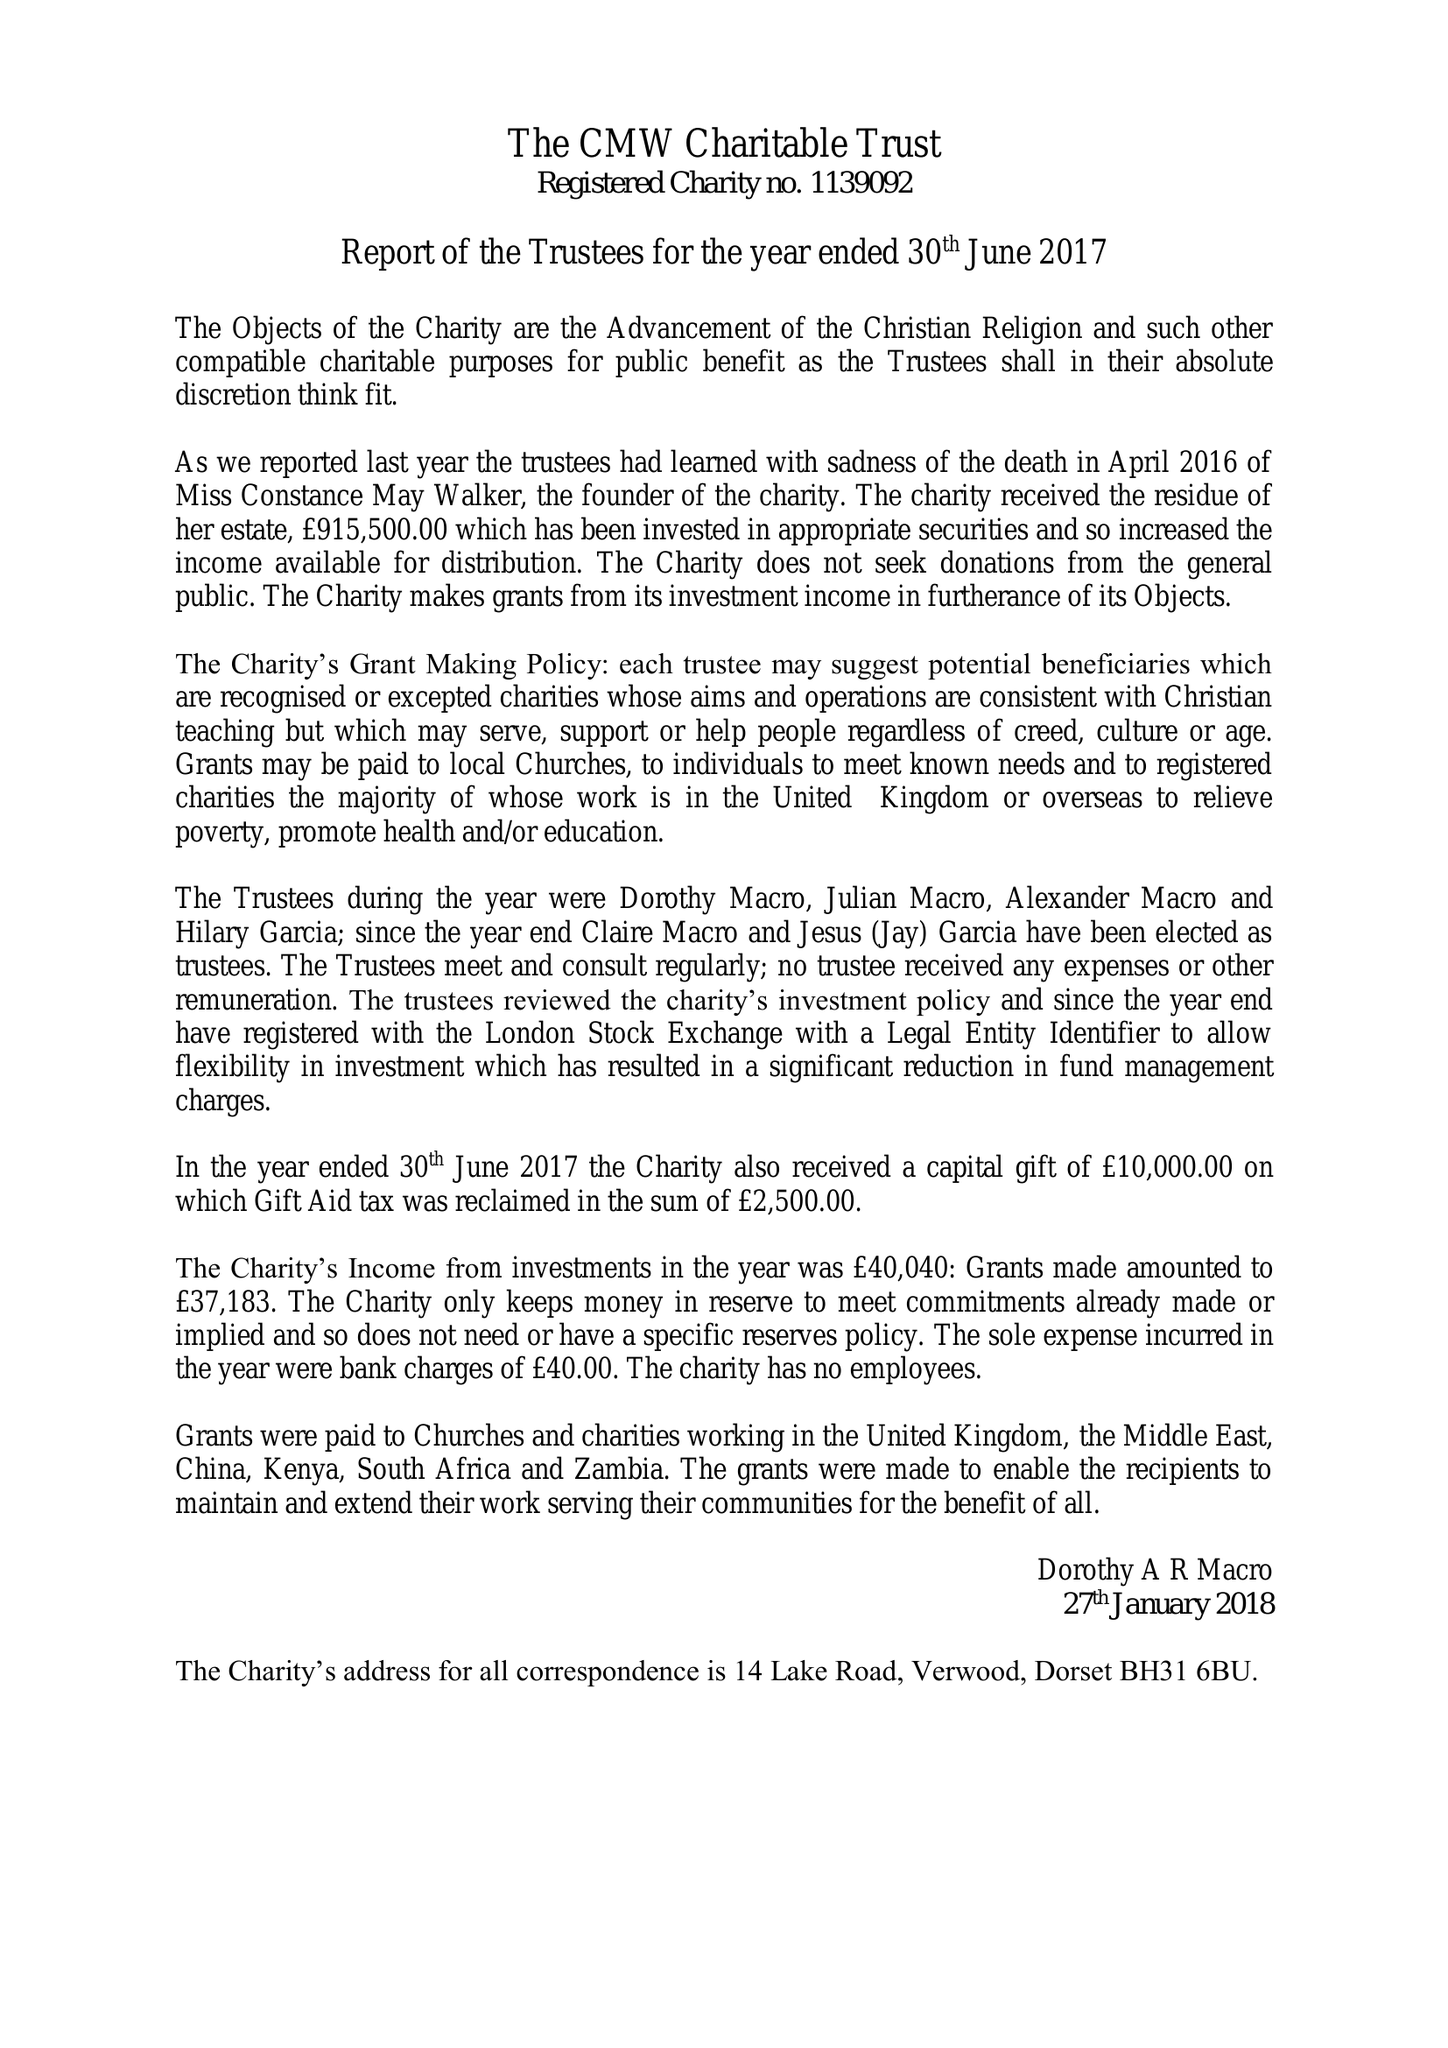What is the value for the charity_name?
Answer the question using a single word or phrase. The Cmw Charitable Trust 